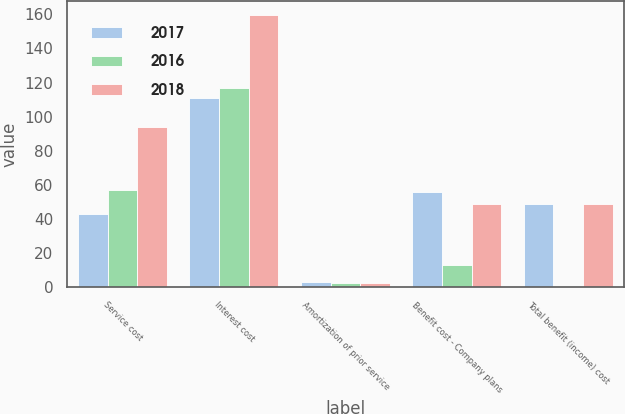<chart> <loc_0><loc_0><loc_500><loc_500><stacked_bar_chart><ecel><fcel>Service cost<fcel>Interest cost<fcel>Amortization of prior service<fcel>Benefit cost - Company plans<fcel>Total benefit (income) cost<nl><fcel>2017<fcel>42.8<fcel>111.1<fcel>2.9<fcel>56.1<fcel>49<nl><fcel>2016<fcel>56.9<fcel>116.8<fcel>2.6<fcel>12.9<fcel>0.9<nl><fcel>2018<fcel>93.8<fcel>159.8<fcel>2.7<fcel>49<fcel>49<nl></chart> 